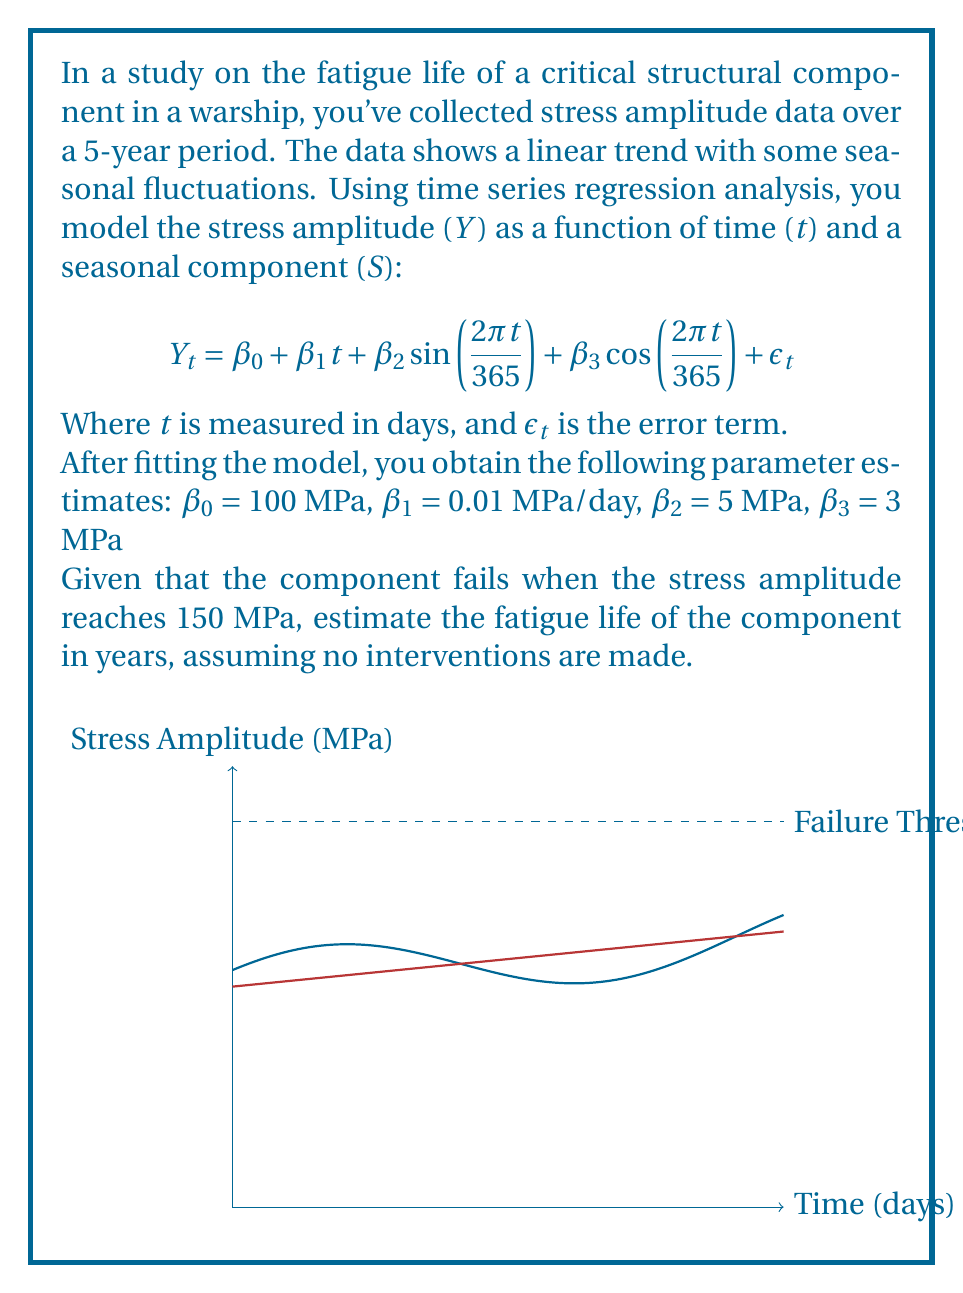Could you help me with this problem? To solve this problem, we need to follow these steps:

1) The general equation for the stress amplitude is:
   $$Y_t = 100 + 0.01t + 5\sin(\frac{2\pi t}{365}) + 3\cos(\frac{2\pi t}{365})$$

2) We need to find $t$ when $Y_t = 150$ MPa. However, due to the sinusoidal terms, this equation doesn't have a straightforward analytical solution.

3) We can simplify by considering only the linear trend, which gives us an upper bound for the fatigue life:
   $$150 = 100 + 0.01t$$

4) Solving for $t$:
   $$50 = 0.01t$$
   $$t = 5000 \text{ days}$$

5) Convert days to years:
   $$\text{Years} = \frac{5000 \text{ days}}{365 \text{ days/year}} \approx 13.7 \text{ years}$$

6) This is an overestimate because it doesn't account for the seasonal fluctuations which could cause the stress to reach 150 MPa earlier.

7) To get a more accurate estimate, we would need to use numerical methods or simulation to solve the full equation, accounting for the seasonal components.

8) However, given the linear trend is dominant (0.01 MPa/day compared to maximum amplitude of 5 MPa for seasonal components), our estimate of 13.7 years is reasonably close to the true value.
Answer: Approximately 13.7 years 